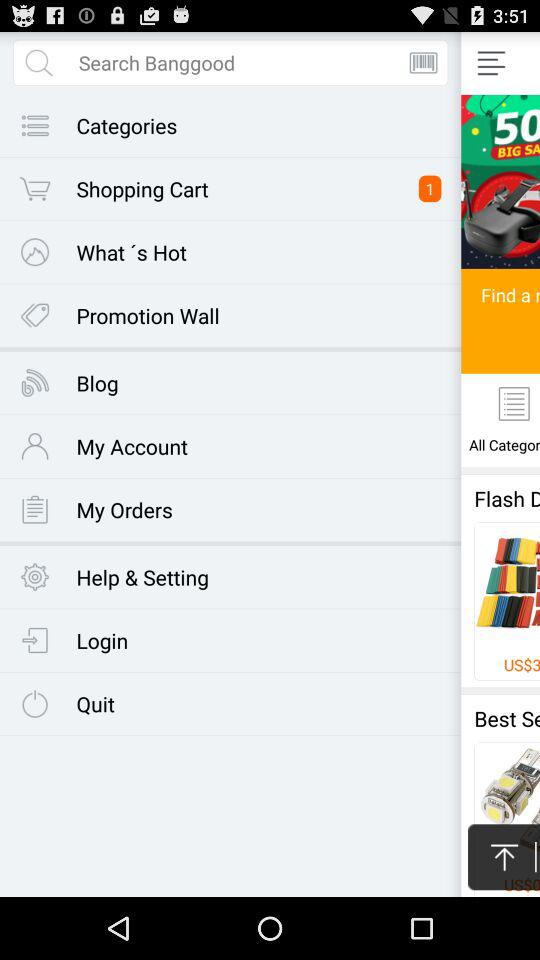What is the price of the product? The price of the product is US $20.99. 